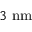Convert formula to latex. <formula><loc_0><loc_0><loc_500><loc_500>3 \ n m</formula> 